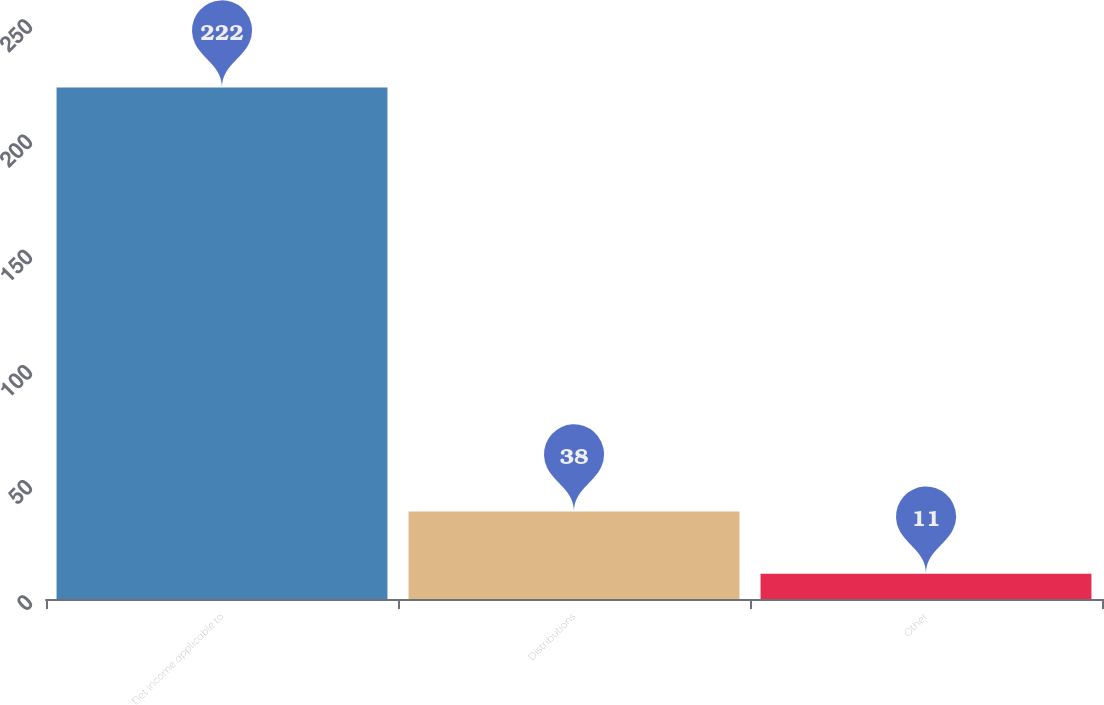Convert chart to OTSL. <chart><loc_0><loc_0><loc_500><loc_500><bar_chart><fcel>Net income applicable to<fcel>Distributions<fcel>Other<nl><fcel>222<fcel>38<fcel>11<nl></chart> 